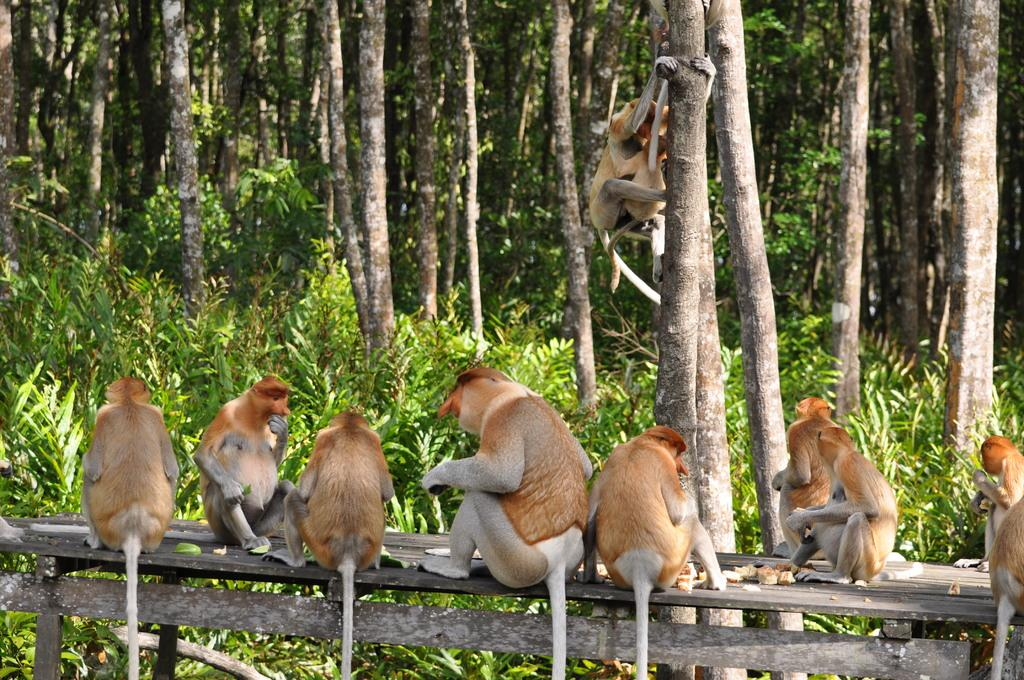What type of animals are present in the image? There are monkeys in the image. What are some of the monkeys doing in the image? Some monkeys are sitting on a wooden object, and there is a monkey climbing a tree. What type of vegetation can be seen in the image? There are trees and plants in the image. What type of beam is being used by the monkeys to test their strength in the image? There is no beam present in the image, and the monkeys are not testing their strength. 